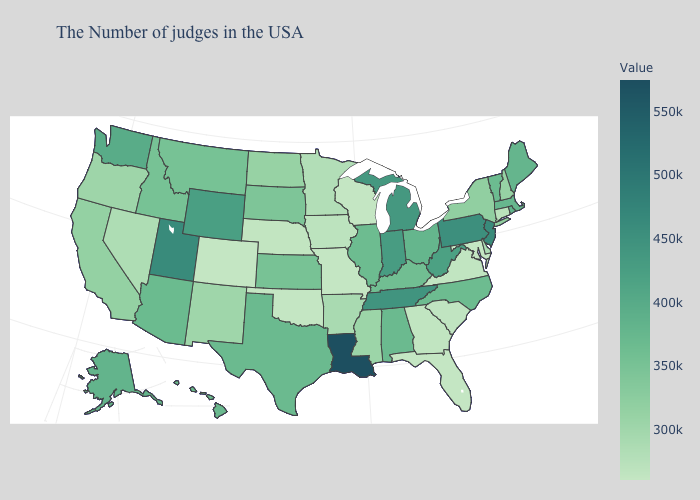Which states have the lowest value in the Northeast?
Give a very brief answer. Connecticut. Among the states that border Colorado , which have the lowest value?
Write a very short answer. Oklahoma. Does Montana have a higher value than Oregon?
Answer briefly. Yes. Among the states that border Pennsylvania , does Maryland have the lowest value?
Answer briefly. Yes. 